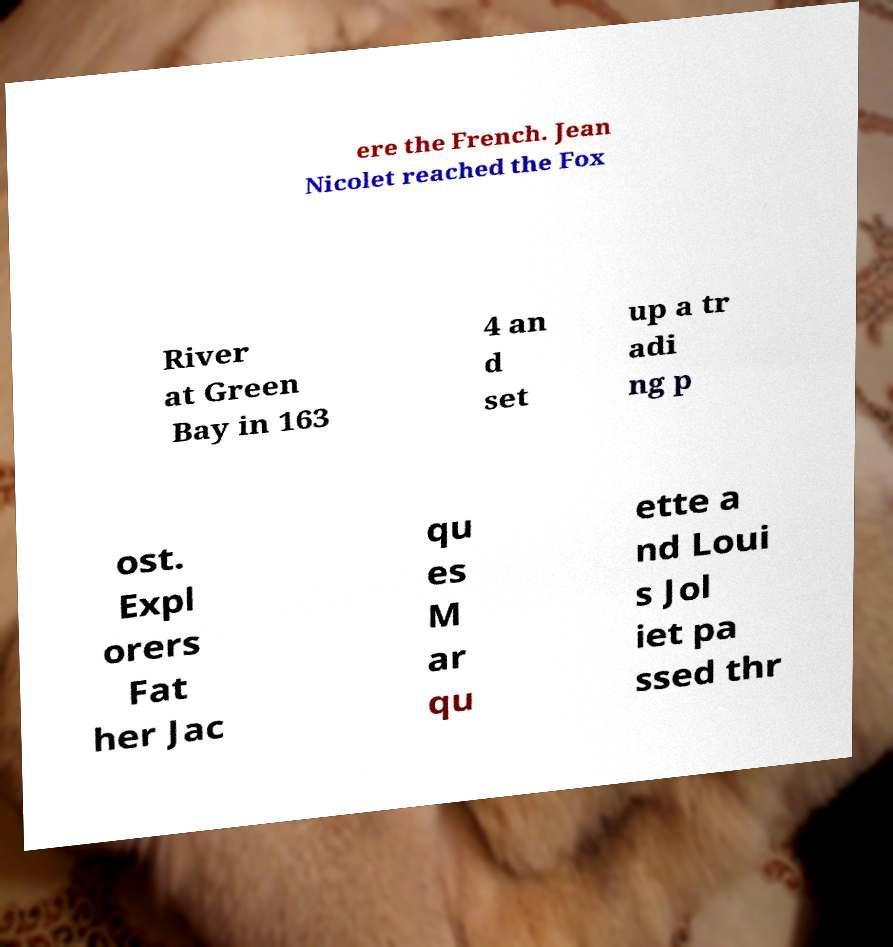Could you assist in decoding the text presented in this image and type it out clearly? ere the French. Jean Nicolet reached the Fox River at Green Bay in 163 4 an d set up a tr adi ng p ost. Expl orers Fat her Jac qu es M ar qu ette a nd Loui s Jol iet pa ssed thr 